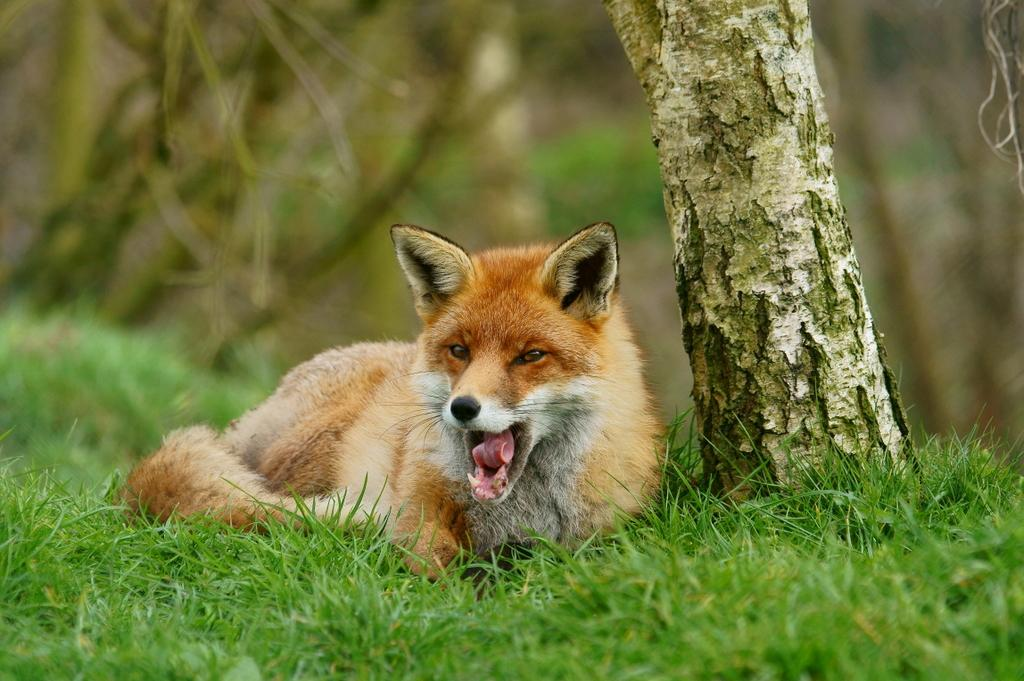What type of animal can be seen in the image? There is an animal in the image, but the specific type cannot be determined from the provided facts. Where is the animal located in the image? The animal is lying on a grass field in the image. What can be seen in the background of the image? There is a group of trees in the background of the image. What type of elbow is visible in the image? There is no elbow present in the image; it features an animal lying on a grass field with trees in the background. 